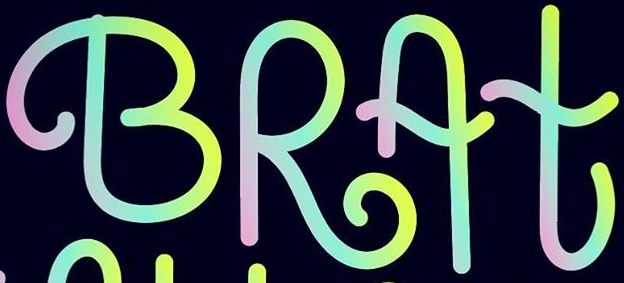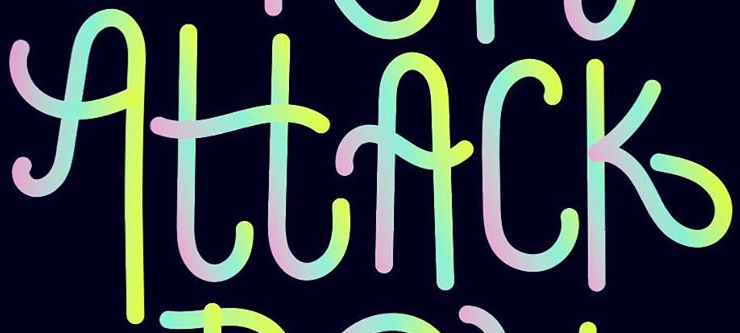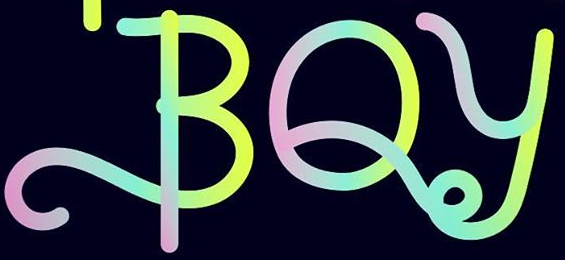What words are shown in these images in order, separated by a semicolon? BRAt; AttAck; BOy 